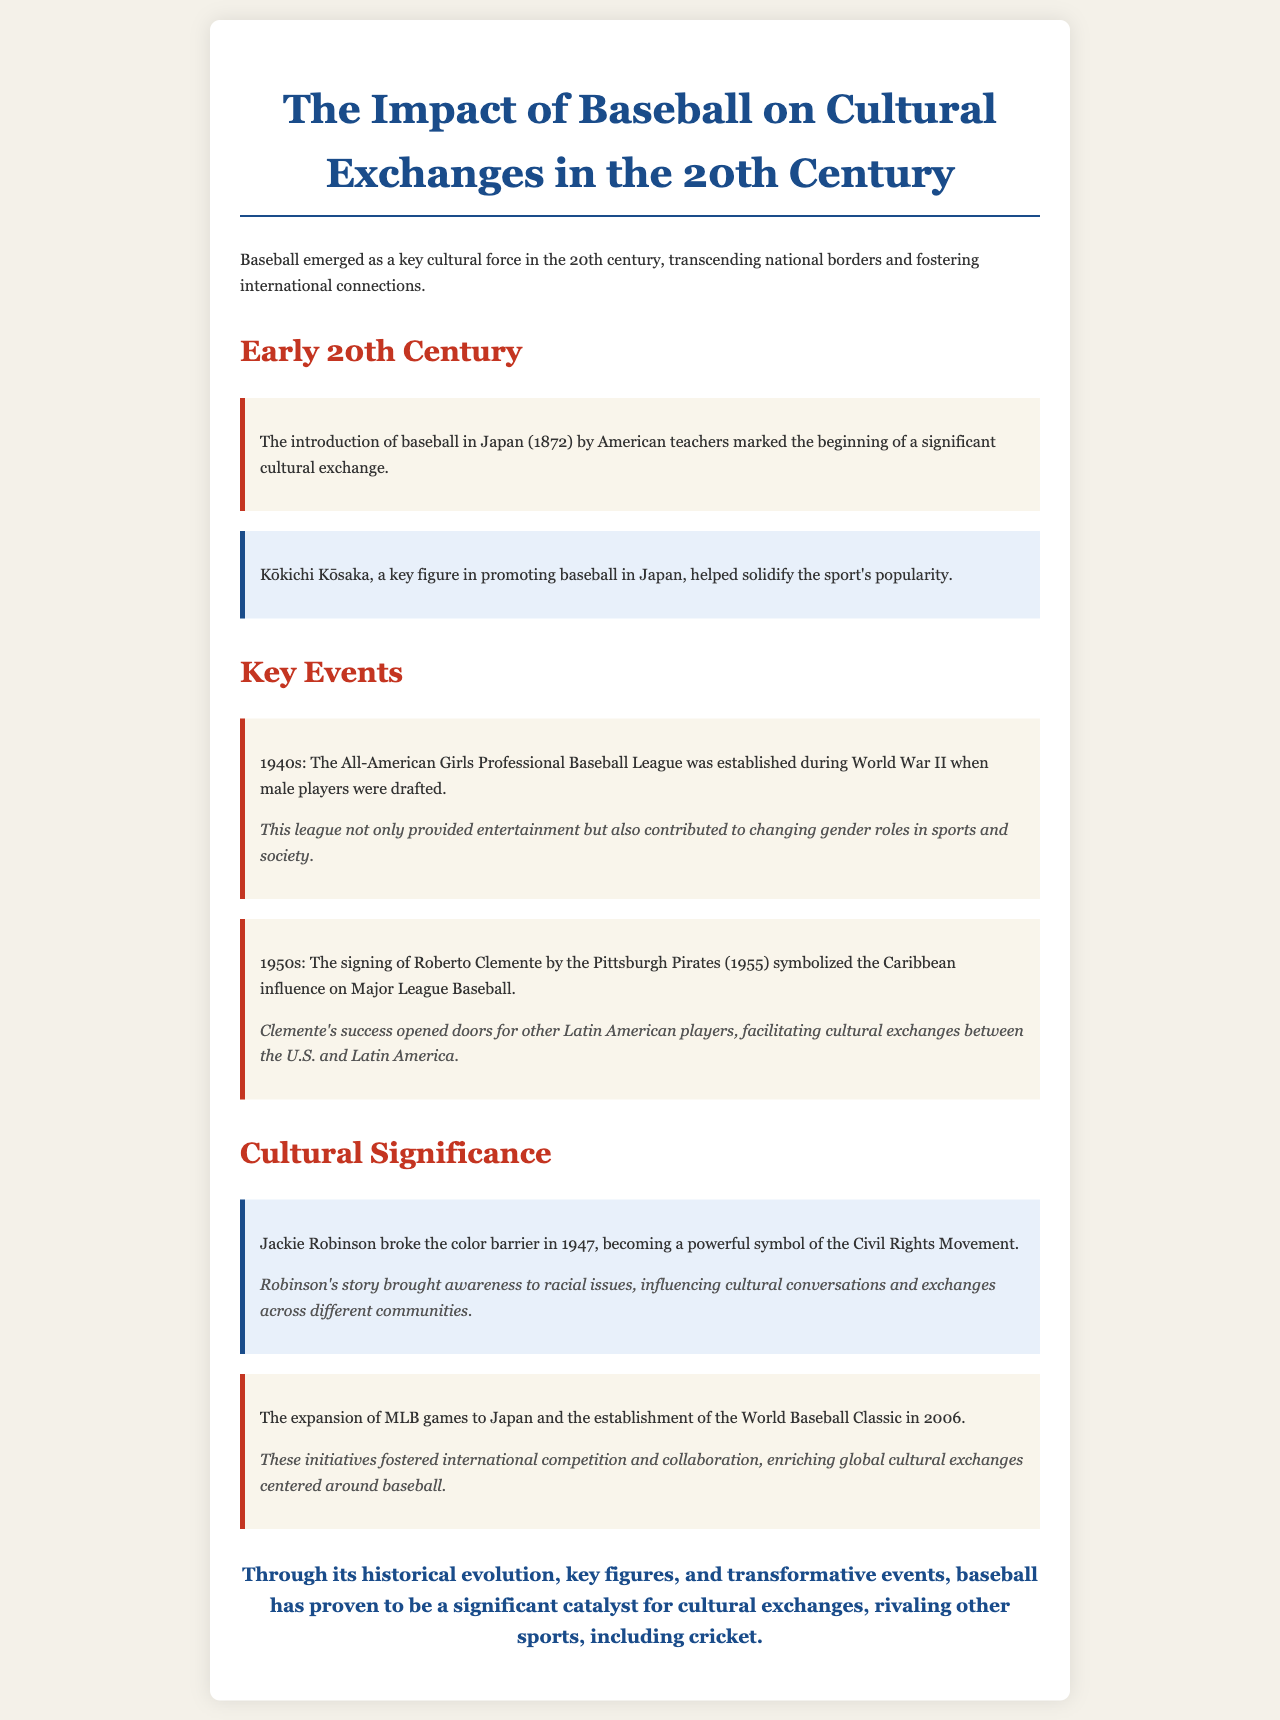What year was baseball introduced in Japan? The document states that baseball was introduced in Japan in the year 1872.
Answer: 1872 Who played a key role in promoting baseball in Japan? The document mentions Kōkichi Kōsaka as a key figure in promoting baseball in Japan.
Answer: Kōkichi Kōsaka What year did Jackie Robinson break the color barrier? According to the document, Jackie Robinson broke the color barrier in 1947.
Answer: 1947 What league was established during World War II? The document refers to the All-American Girls Professional Baseball League established during World War II.
Answer: All-American Girls Professional Baseball League What significance did Roberto Clemente's signing have? The document explains that Roberto Clemente’s signing symbolized the Caribbean influence on Major League Baseball.
Answer: Caribbean influence How did the establishment of the World Baseball Classic impact cultural exchanges? The document states that it fostered international competition and collaboration.
Answer: Fostered international competition and collaboration What is an effect of the All-American Girls Professional Baseball League? The document indicates that this league contributed to changing gender roles in sports and society.
Answer: Changing gender roles What was the document's conclusion about baseball? The document concludes that baseball is a significant catalyst for cultural exchanges, rivaling other sports.
Answer: Significant catalyst for cultural exchanges 